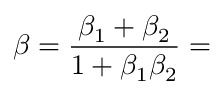Convert formula to latex. <formula><loc_0><loc_0><loc_500><loc_500>\beta = { \frac { \beta _ { 1 } + \beta _ { 2 } } { 1 + \beta _ { 1 } \beta _ { 2 } } } =</formula> 